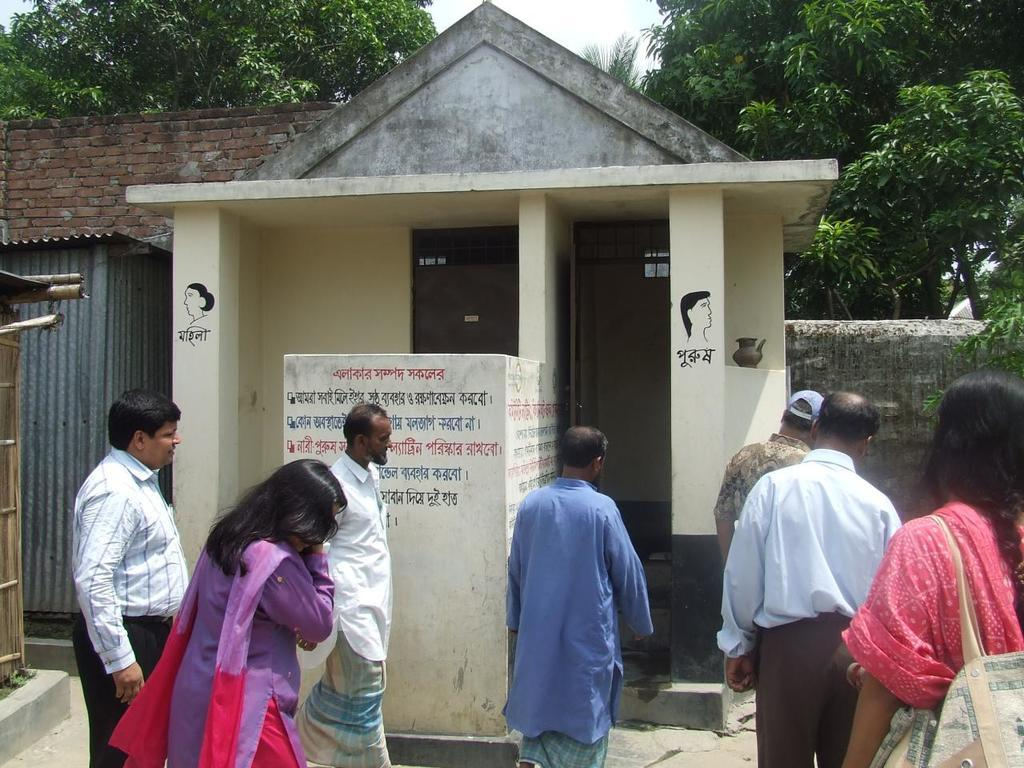What is the main subject of the image? The main subject of the image is people in front of a public toilet. What can be seen on the left side of the image? There are sheds on the left side of the image. What type of vegetation is visible at the top side of the image? There are trees at the top side of the image. What is the price of the farm in the image? There is no farm present in the image, so it is not possible to determine the price. 